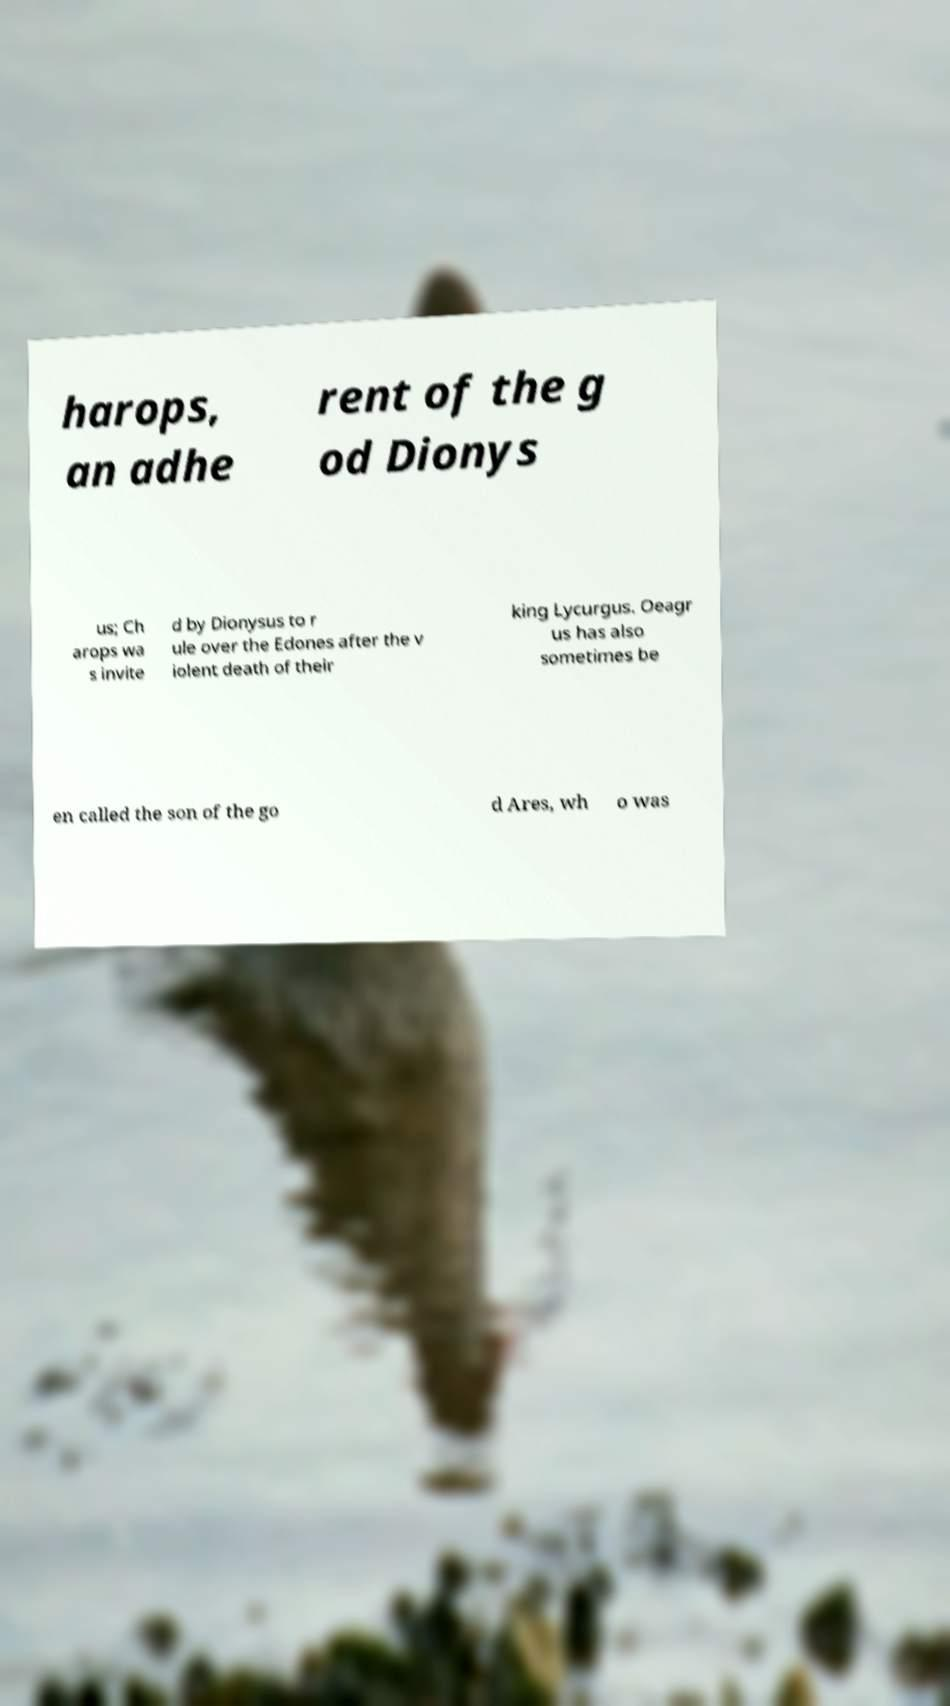I need the written content from this picture converted into text. Can you do that? harops, an adhe rent of the g od Dionys us; Ch arops wa s invite d by Dionysus to r ule over the Edones after the v iolent death of their king Lycurgus. Oeagr us has also sometimes be en called the son of the go d Ares, wh o was 